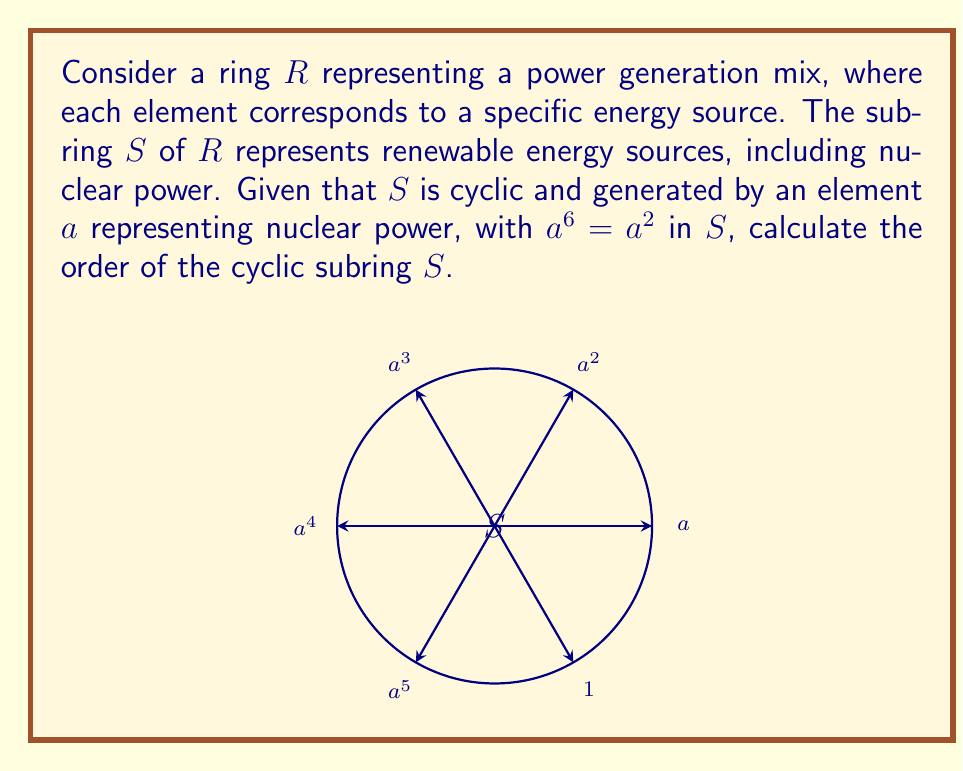Solve this math problem. To find the order of the cyclic subring $S$, we need to determine the smallest positive integer $n$ such that $a^n = 1$ in $S$. Let's approach this step-by-step:

1) We're given that $a^6 = a^2$ in $S$. This means that multiplying both sides by $a^{-2}$, we get:
   $a^4 = 1$

2) This suggests that the order of $a$ is a divisor of 4. The possible orders are 1, 2, and 4.

3) If the order were 1, then $a = 1$, which is trivial and doesn't represent a meaningful power source.

4) If the order were 2, then $a^2 = 1$. But this contradicts the given information that $a^6 = a^2$, because if $a^2 = 1$, then $a^6 = (a^2)^3 = 1^3 = 1 \neq a^2$.

5) Therefore, the order of $a$ must be 4.

6) In a cyclic group (or subring) generated by an element of order 4, the elements are:
   $\{1, a, a^2, a^3\}$

7) Since $S$ is generated by $a$, and $a$ has order 4, the order of the cyclic subring $S$ is also 4.

This result aligns with the policymaker's perspective, as it suggests a balanced mix of four energy sources in the renewable category, including nuclear power.
Answer: 4 